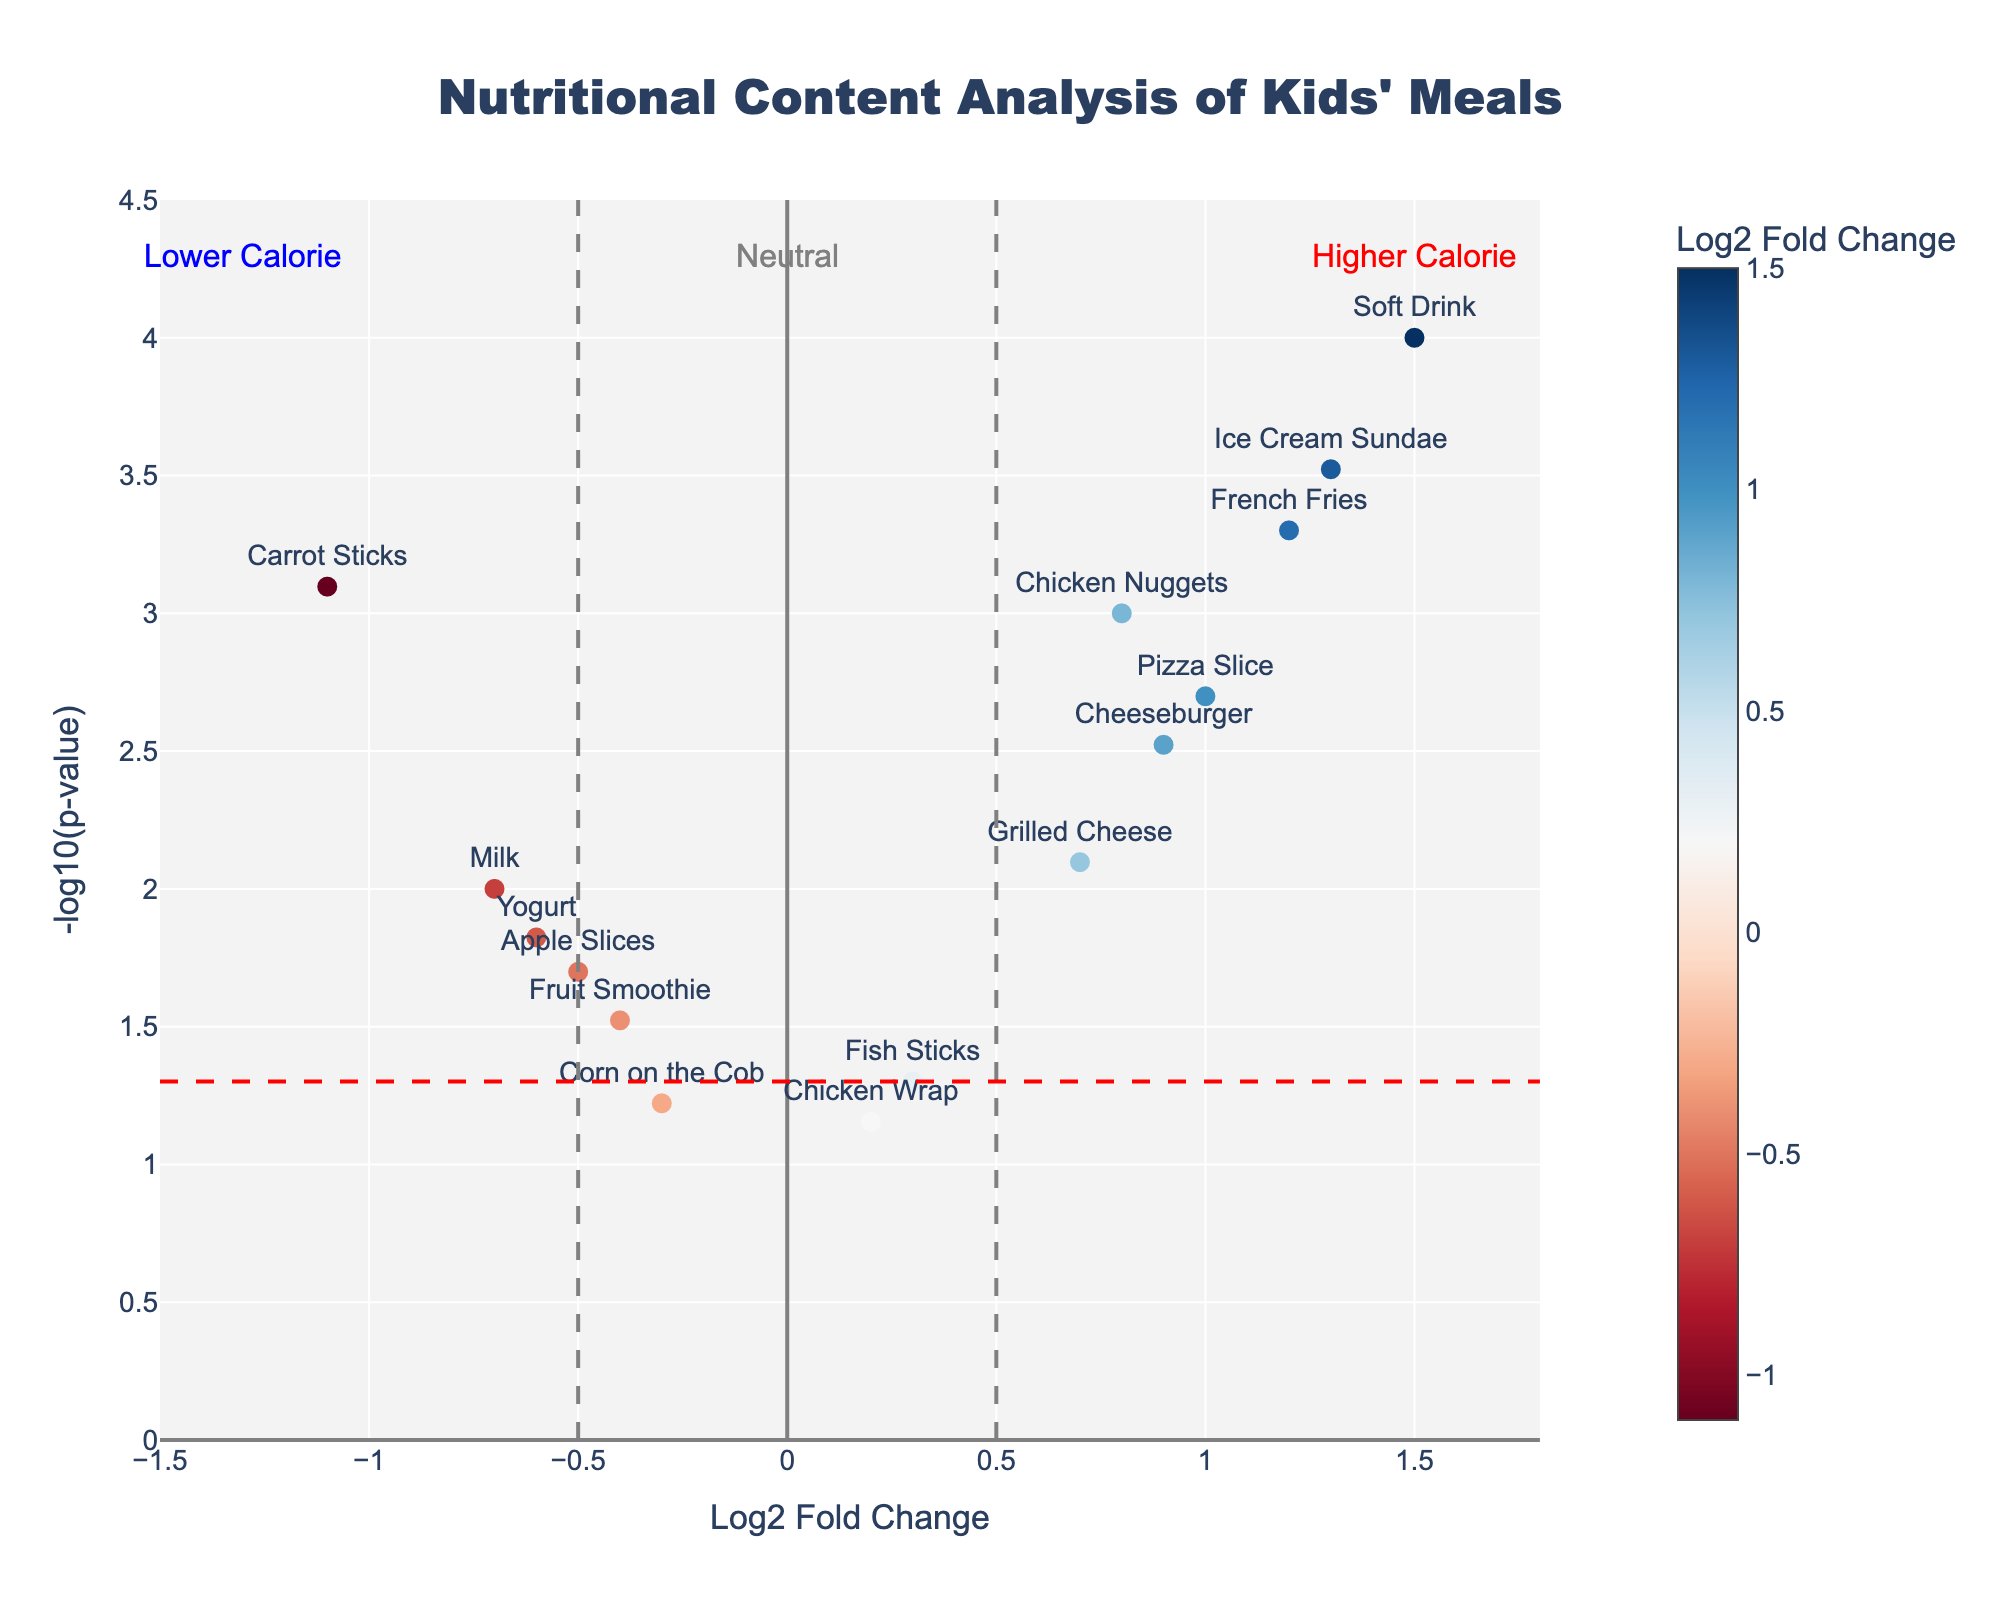What is the title of the figure? The title can be found at the top center of the figure. It is written in large font and provides the main context of the plot.
Answer: Nutritional Content Analysis of Kids' Meals How many food items have a -log10(p-value) greater than 3? By observing the vertical positions of data points, find the ones that are higher on the y-axis and above the y=3 line.
Answer: Three (Soft Drink, Ice Cream Sundae, French Fries) Which food item has the highest log2 fold change? Identify the point that is furthest to the right on the x-axis and refer to its label.
Answer: Soft Drink How many food items have a log2 fold change between -0.5 and 0.5? Check the number of points that fall within the vertical lines at x=-0.5 and x=0.5.
Answer: Four (Apple Slices, Milk, Yogurt, Grilled Cheese) Which food item has the lowest p-value? Determine which point is highest on the y-axis because -log10(p-value) increases as p-value decreases.
Answer: Soft Drink What does a positive log2 fold change indicate about the calorie count? Refer to the annotations on the plot which explain that positive values indicate higher calories.
Answer: Higher calorie How many points are considered significantly different if the significance threshold is p-value < 0.05? Identify points above the horizontal line y=-log10(0.05). Count all points above this line.
Answer: Eleven Which item has the smallest change in calorie count and is statistically insignificant? Identify the point closest to log2 fold change=0 with a p-value above 0.05 (lower on y-axis).
Answer: Chicken Wrap Are there more items with an increase or decrease in calorie count if log2 fold change is considered? Count the points on the positive side and compare with the count on the negative side of the x-axis.
Answer: More items with an increase What food items have lower calories and are statistically significant? Look for points on the left side of x=-0.5 that are above the horizontal line y=-log10(0.05).
Answer: Apple Slices, Milk, Yogurt, Carrot Sticks, Fruit Smoothie 